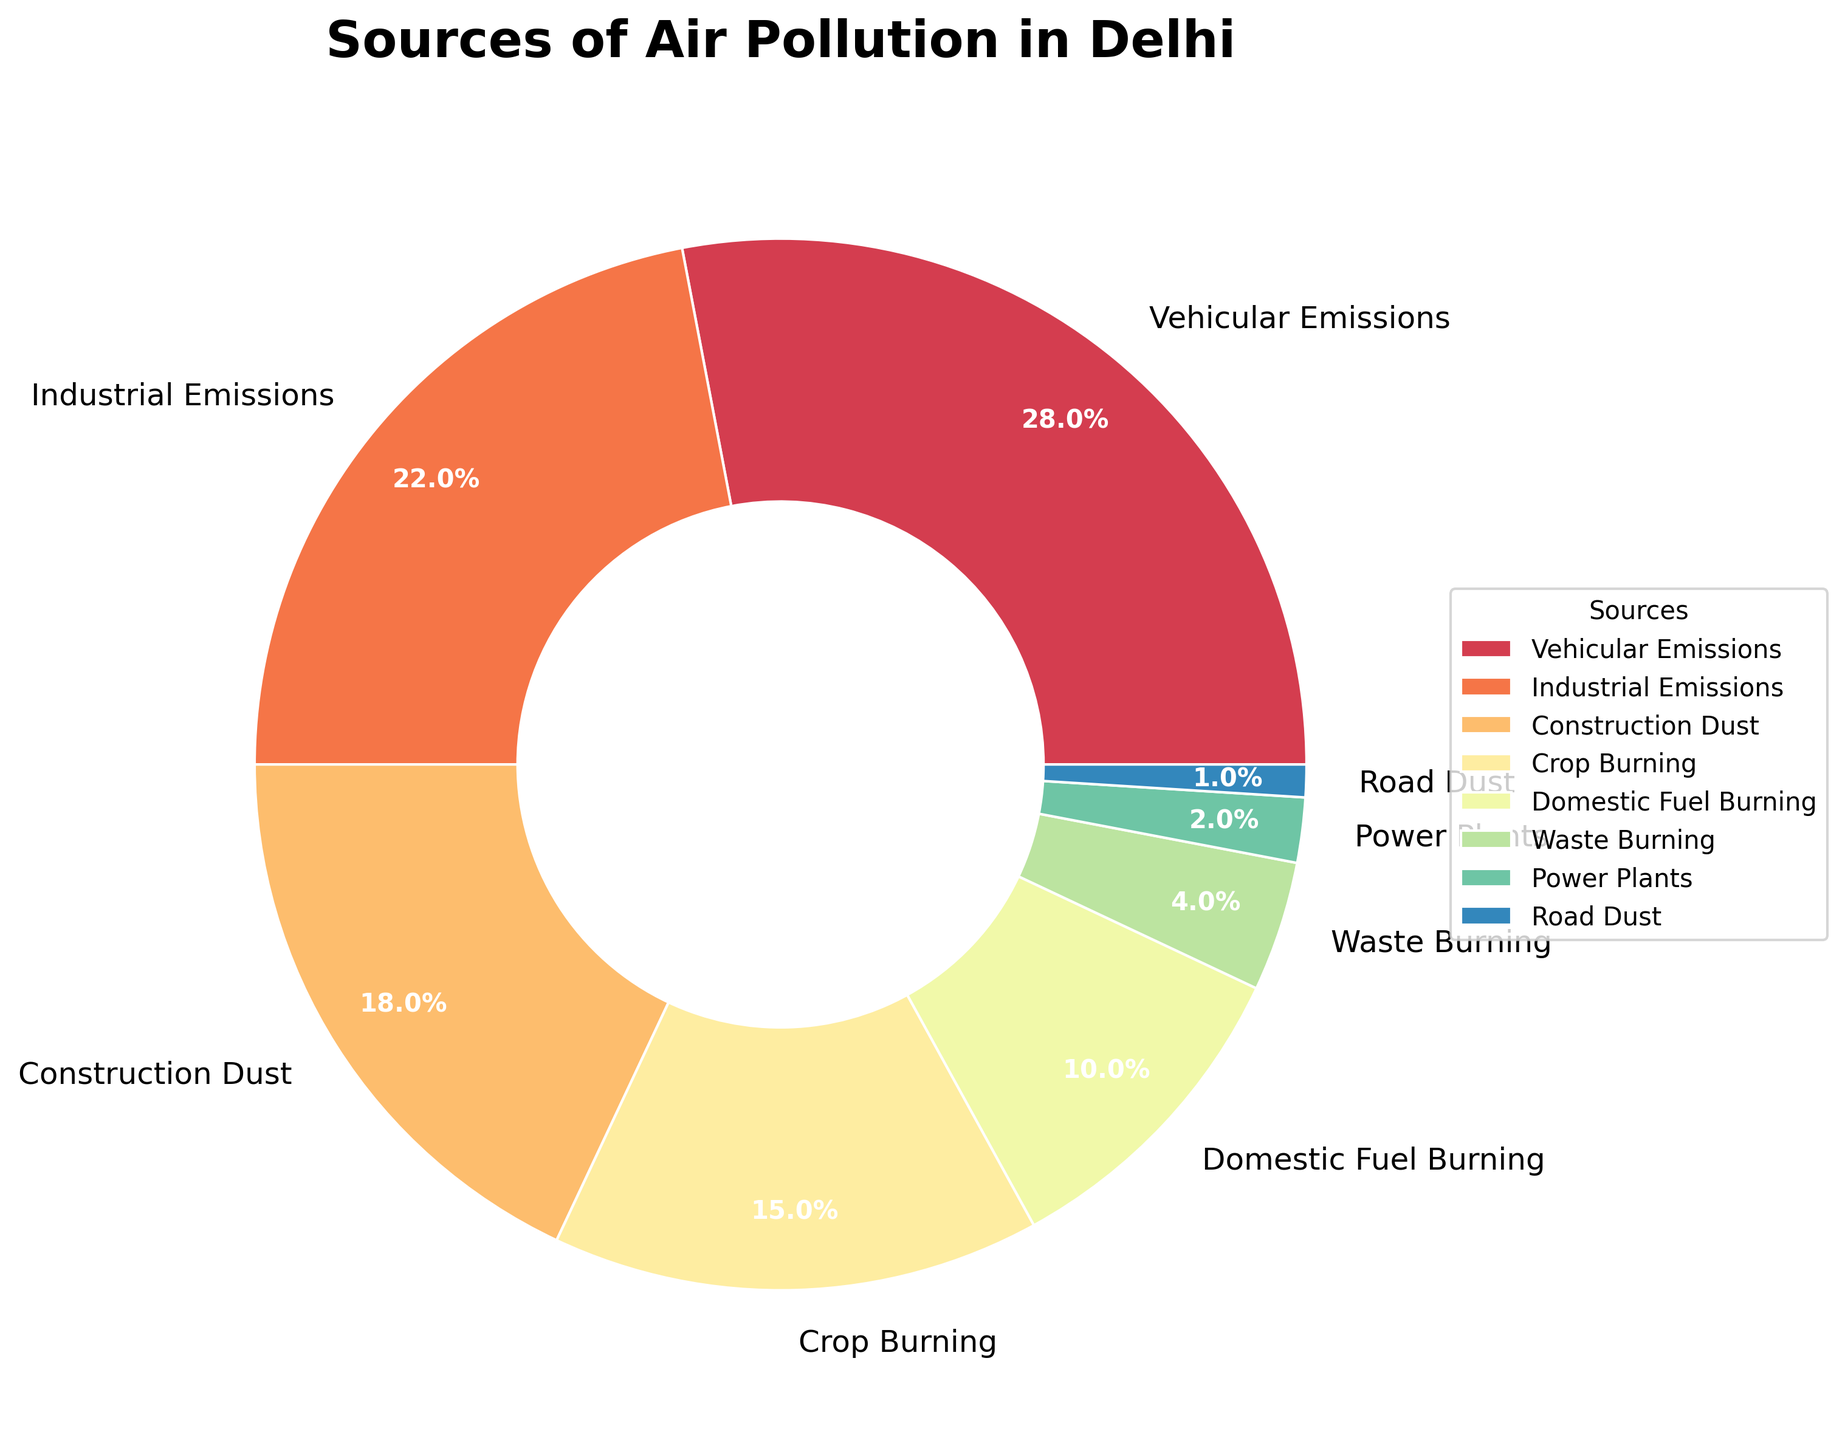what's the largest source of air pollution in Delhi according to the pie chart? The largest segment in the pie chart is labeled "Vehicular Emissions" with a percentage of 28%. Hence, Vehicular Emissions is the largest source of air pollution.
Answer: Vehicular Emissions Which source contributes the least to air pollution in Delhi? The smallest segment in the pie chart is "Road Dust" with a percentage of 1%. Thus, Road Dust contributes the least to air pollution.
Answer: Road Dust Which two sources combined contribute more than 50% to air pollution in Delhi? The two largest segments are Vehicular Emissions (28%) and Industrial Emissions (22%). Adding these together: 28% + 22% = 50%. Therefore, Vehicular Emissions and Industrial Emissions combined contribute more than 50% to air pollution.
Answer: Vehicular Emissions and Industrial Emissions What is the combined percentage of air pollution from domestic fuel burning and waste burning? Domestic Fuel Burning has a percentage of 10% and Waste Burning has a percentage of 4%. Adding these together: 10% + 4% = 14%. Therefore, the combined percentage is 14%.
Answer: 14% How does the contribution of crop burning compare to that of construction dust? The percentage for Crop Burning is 15% and for Construction Dust it is 18%. Therefore, Construction Dust contributes more to air pollution than Crop Burning.
Answer: Construction Dust contributes more What is the difference between the percentage contribution of vehicular emissions and power plants? The percentage of Vehicular Emissions is 28% and for Power Plants it is 2%. Subtracting these: 28% - 2% = 26%. So, the difference is 26%.
Answer: 26% How many sources contribute less than 5% to air pollution? By looking at the pie chart, Waste Burning (4%), Power Plants (2%), and Road Dust (1%) each contribute less than 5%. Therefore, there are three sources.
Answer: 3 What is the percentage contribution of institutional emissions relative to vehicular emissions? Institutional Emissions contribute 22% and Vehicular Emissions contribute 28%. Dividing these: (22 / 28) * 100 ≈ 78.57%. So, Institutional Emissions contribute approximately 78.57% relative to Vehicular Emissions.
Answer: 78.57% Which source's contribution is exactly halfway between construction dust and domestic fuel burning? Construction Dust has 18% and Domestic Fuel Burning has 10%. The halfway point is (18 + 10) / 2 = 14%. The source that is closest to 14% is Crop Burning at 15%, but we need the exact halfway point. Still, Crop Burning is the closest.
Answer: Crop Burning If the contribution of waste burning doubles, will it be greater than that of crop burning? Waste Burning contributes 4%. If it doubles, it becomes 4% * 2 = 8%. Crop Burning contributes 15%. Since 8% is less than 15%, even if Waste Burning doubles, it will not be greater than Crop Burning.
Answer: No 